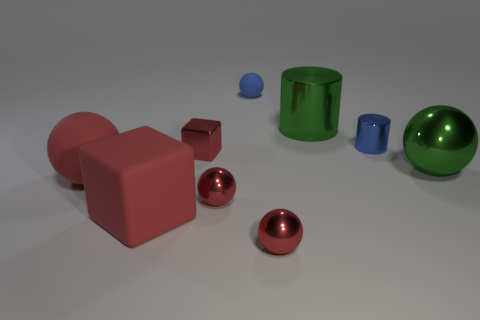Do the big red block and the red object that is behind the big matte sphere have the same material? No, the big red block has a matte finish which diffuses light, giving it a non-reflective appearance, while the red object behind the big matte sphere appears to have a glossy finish, indicating a different material that reflects light and produces a shiny surface. 